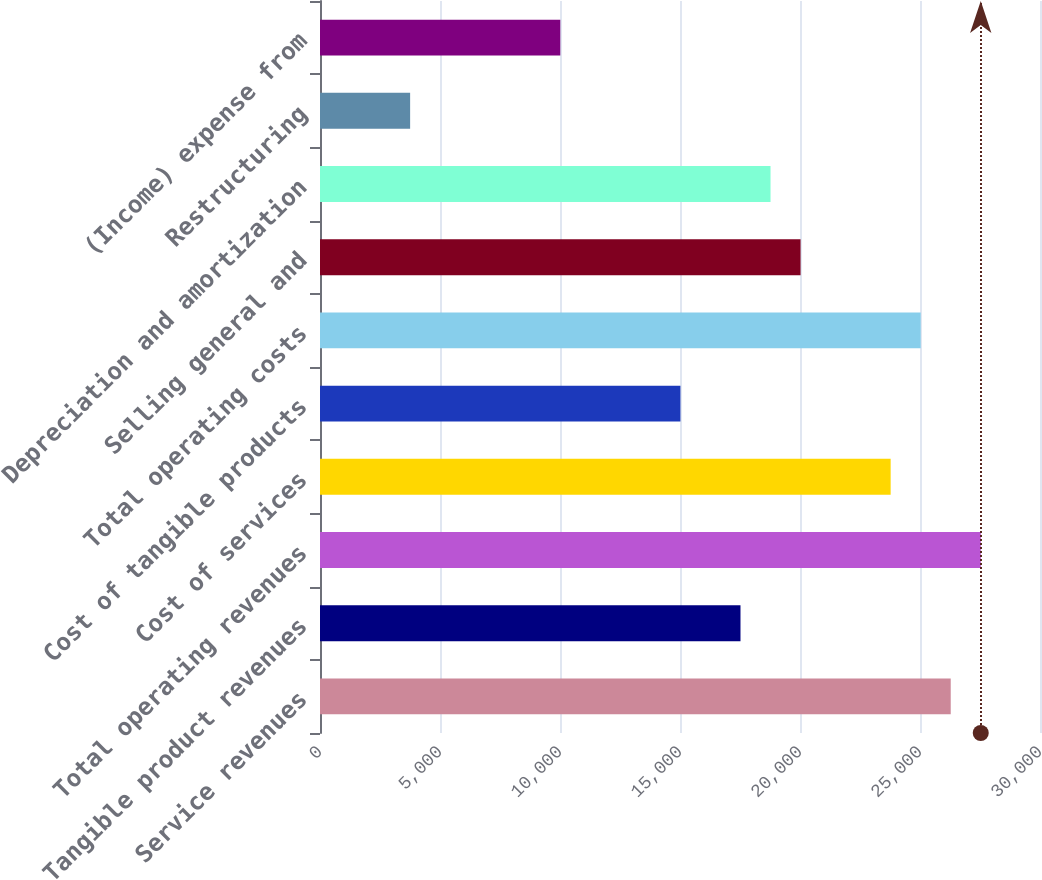Convert chart to OTSL. <chart><loc_0><loc_0><loc_500><loc_500><bar_chart><fcel>Service revenues<fcel>Tangible product revenues<fcel>Total operating revenues<fcel>Cost of services<fcel>Cost of tangible products<fcel>Total operating costs<fcel>Selling general and<fcel>Depreciation and amortization<fcel>Restructuring<fcel>(Income) expense from<nl><fcel>26280<fcel>17520.4<fcel>27531.4<fcel>23777.3<fcel>15017.7<fcel>25028.7<fcel>20023.2<fcel>18771.8<fcel>3755.37<fcel>10012.2<nl></chart> 